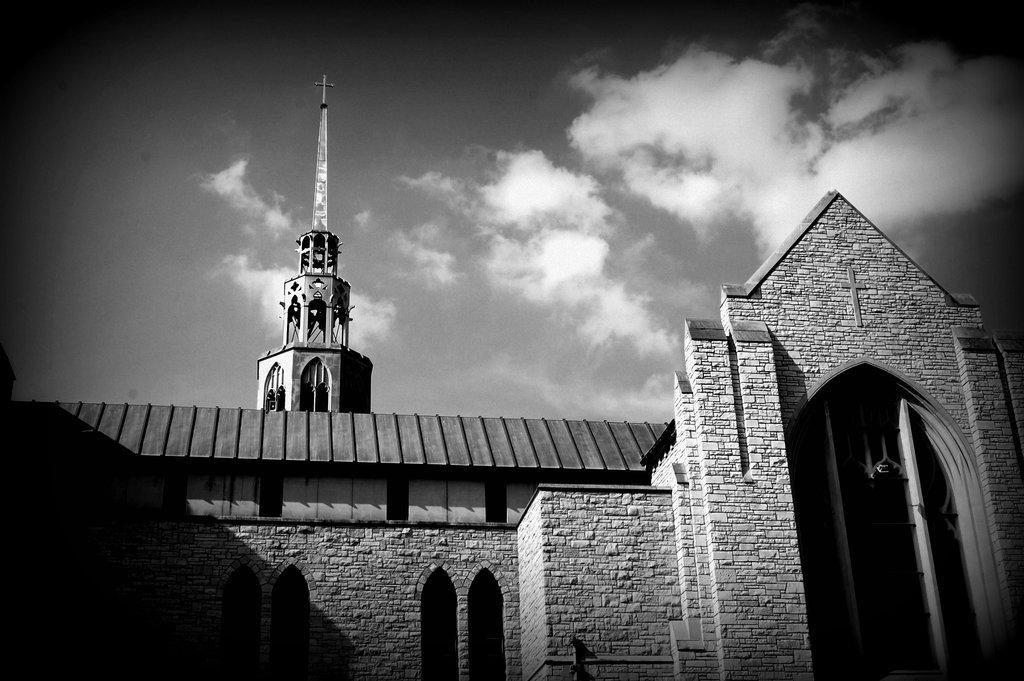What type of structure is present in the image? There is a building in the image. What can be seen in the sky at the top of the image? Clouds are visible in the sky at the top of the image. What color scheme is used in the image? The image is in black and white color. How many snails can be seen crawling on the building in the image? There are no snails present in the image; it only features a building and clouds in the sky. 